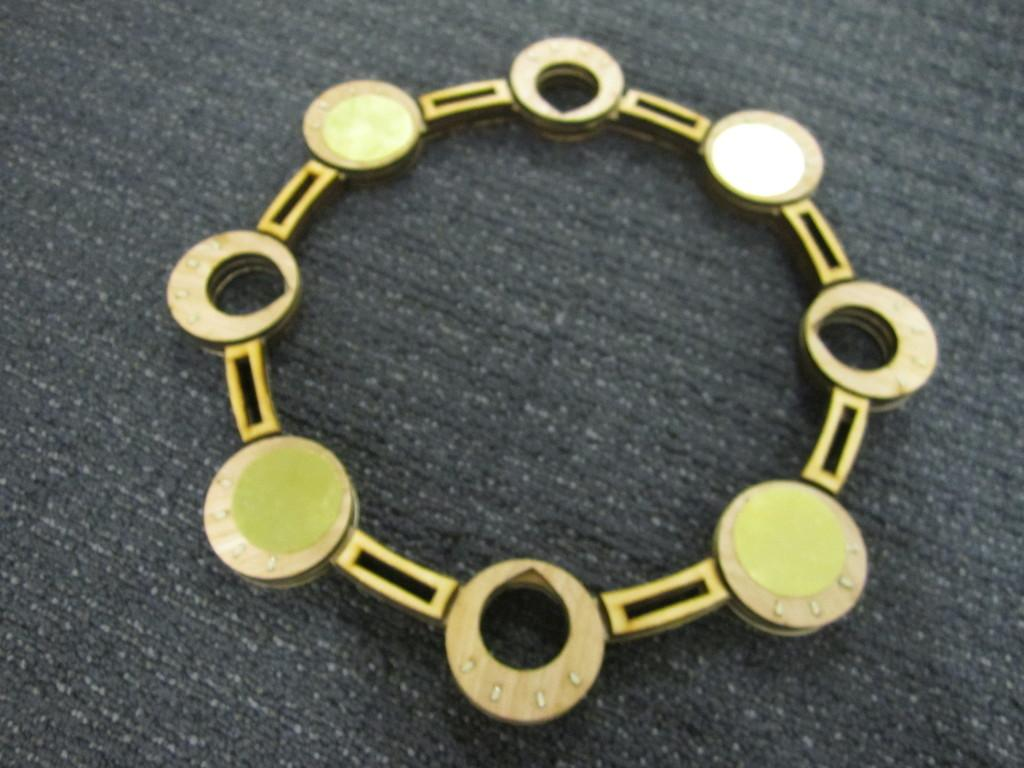What is the main object in the image? There is a bracelet in the image. What is attached to the bracelet? The bracelet has round color objects placed in between it. How many children were born in the image? There is no reference to children or birth in the image; it features a bracelet with round color objects. 